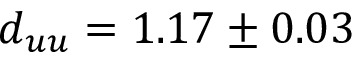<formula> <loc_0><loc_0><loc_500><loc_500>d _ { u u } = 1 . 1 7 \pm 0 . 0 3</formula> 